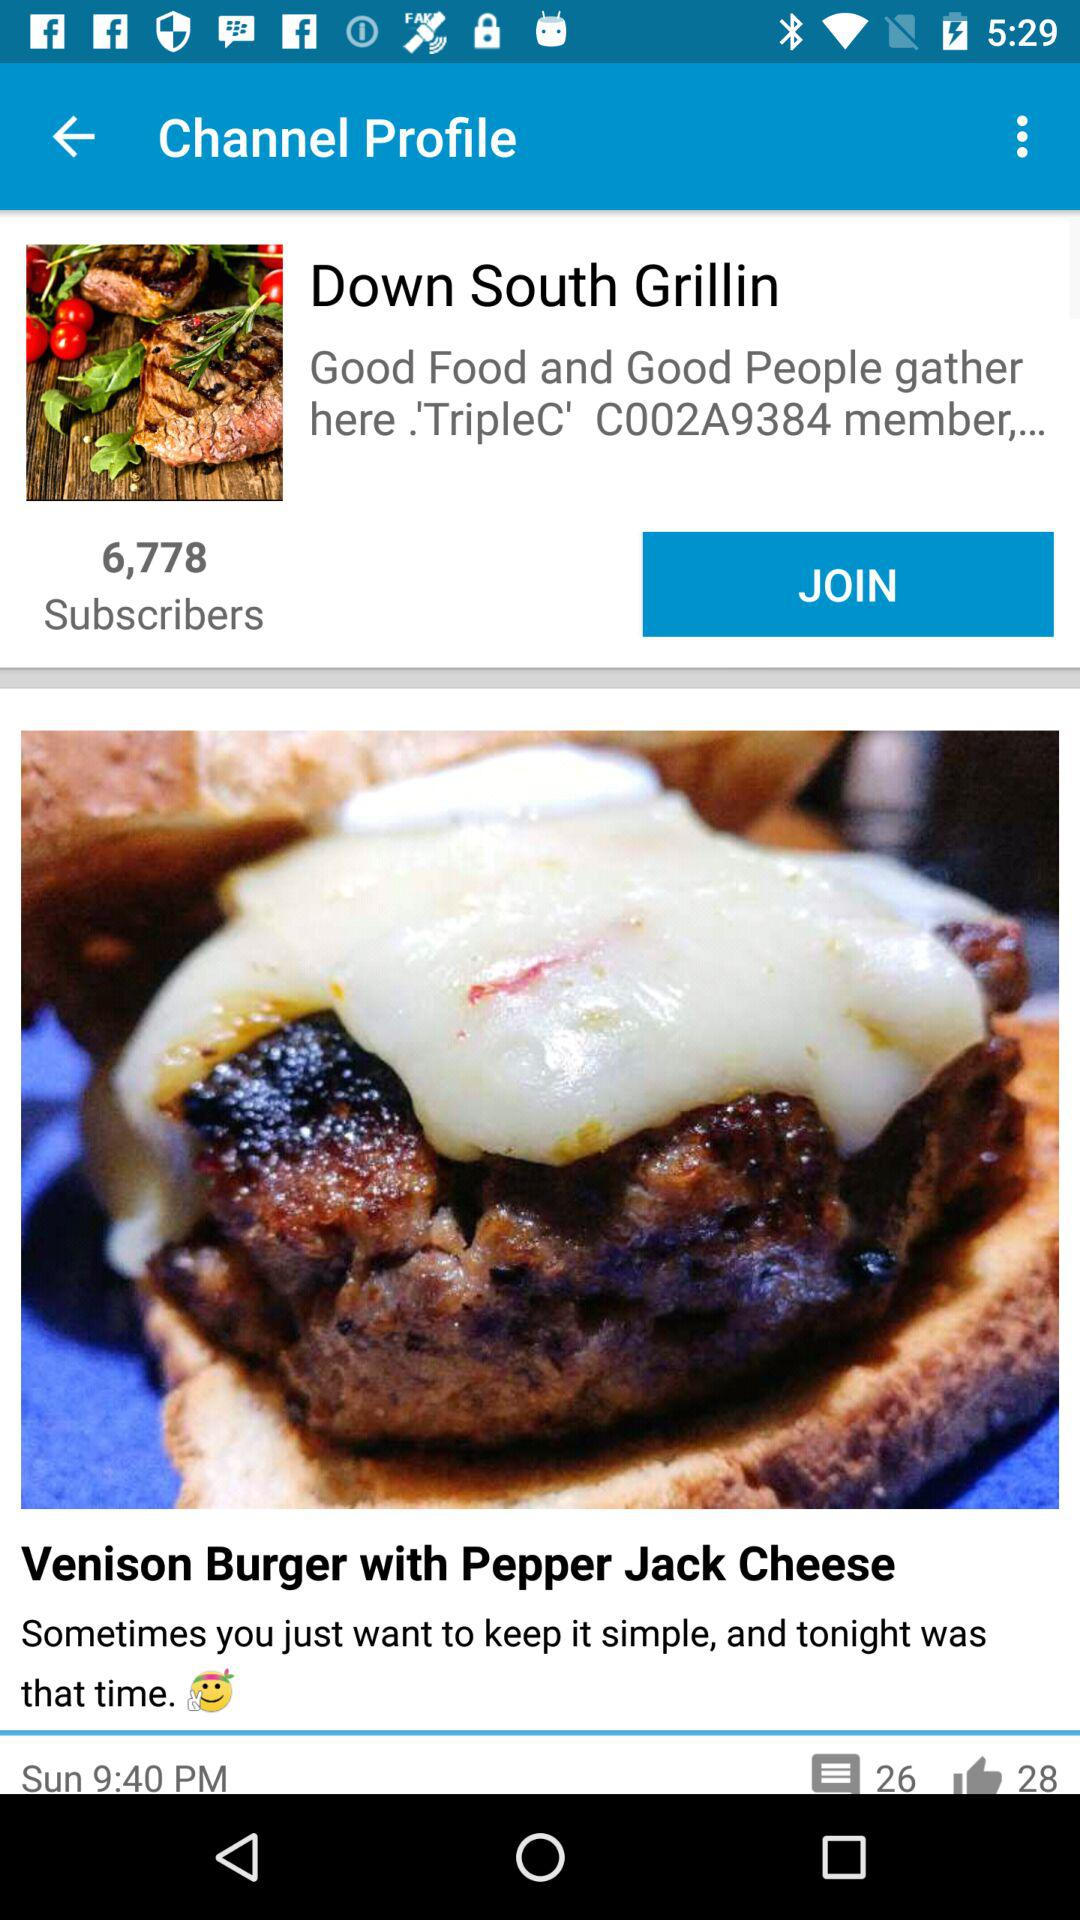How many comments are there on the Venison Burger with Pepper Jack Cheese? There are 26 comments on the Venison Burger with Pepper Jack Cheese. 